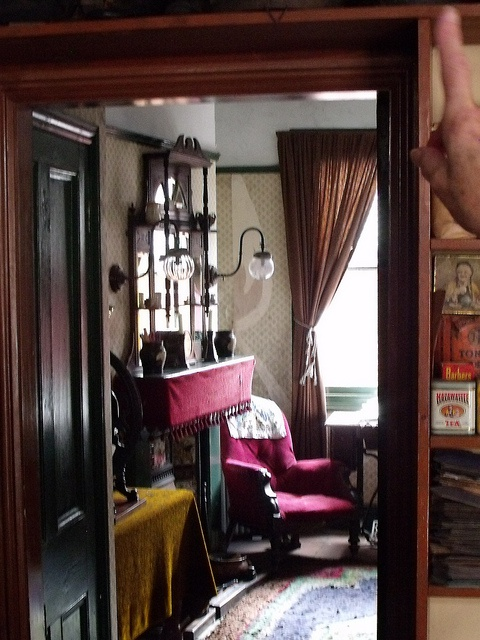Describe the objects in this image and their specific colors. I can see chair in black, white, maroon, and violet tones, couch in black, white, maroon, and violet tones, people in black, brown, and maroon tones, chair in black, gray, and maroon tones, and vase in black, gray, and darkgray tones in this image. 